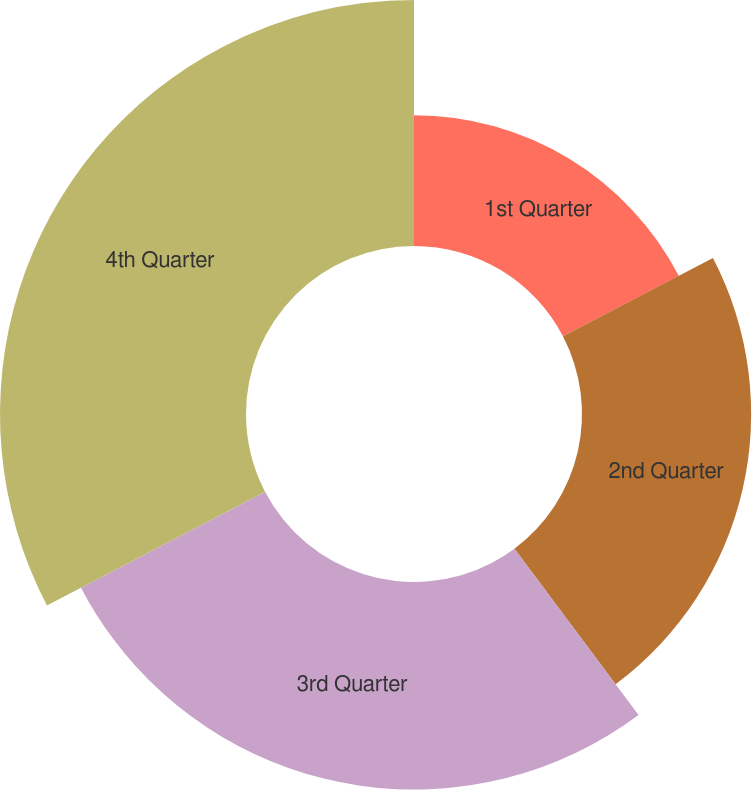Convert chart. <chart><loc_0><loc_0><loc_500><loc_500><pie_chart><fcel>1st Quarter<fcel>2nd Quarter<fcel>3rd Quarter<fcel>4th Quarter<nl><fcel>17.35%<fcel>22.45%<fcel>27.55%<fcel>32.65%<nl></chart> 